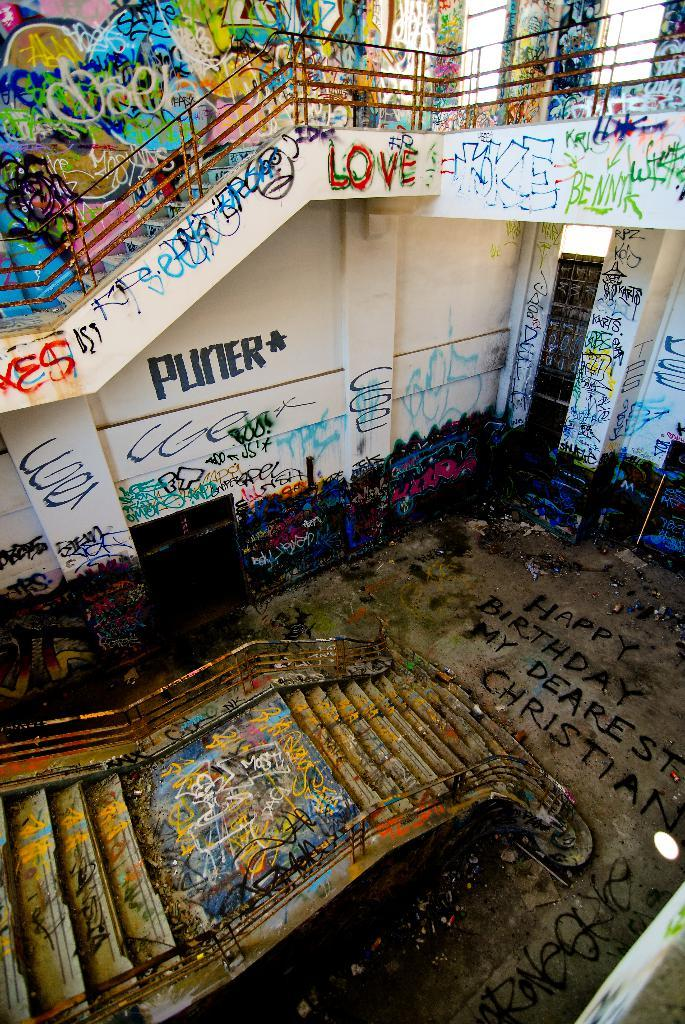What type of architectural feature is present in the image? There are stairs in the image. How is the floor in the image decorated? The floor is decorated with colorful paints. How are the walls in the image decorated? The walls are decorated with colorful paints. Is there any text visible in the image? Yes, there is text written on the walls or floor. What type of wilderness can be seen through the gate in the image? There is no gate or wilderness present in the image. What type of school is depicted in the image? The image does not depict a school; it features stairs, colorful paints, and text. 